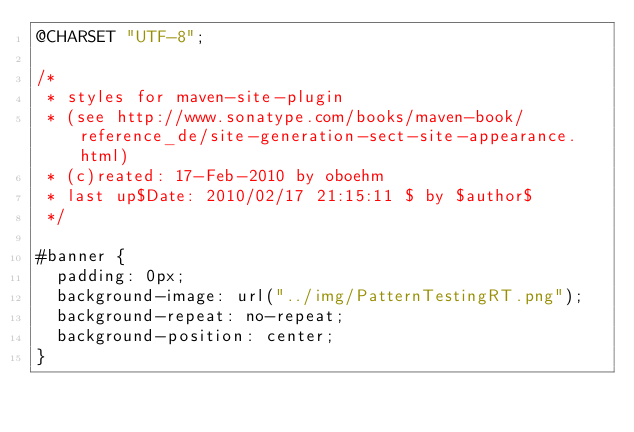<code> <loc_0><loc_0><loc_500><loc_500><_CSS_>@CHARSET "UTF-8";

/*
 * styles for maven-site-plugin
 * (see http://www.sonatype.com/books/maven-book/reference_de/site-generation-sect-site-appearance.html)
 * (c)reated: 17-Feb-2010 by oboehm
 * last up$Date: 2010/02/17 21:15:11 $ by $author$
 */

#banner {
  padding: 0px;
  background-image: url("../img/PatternTestingRT.png");
  background-repeat: no-repeat;
  background-position: center;
}
</code> 